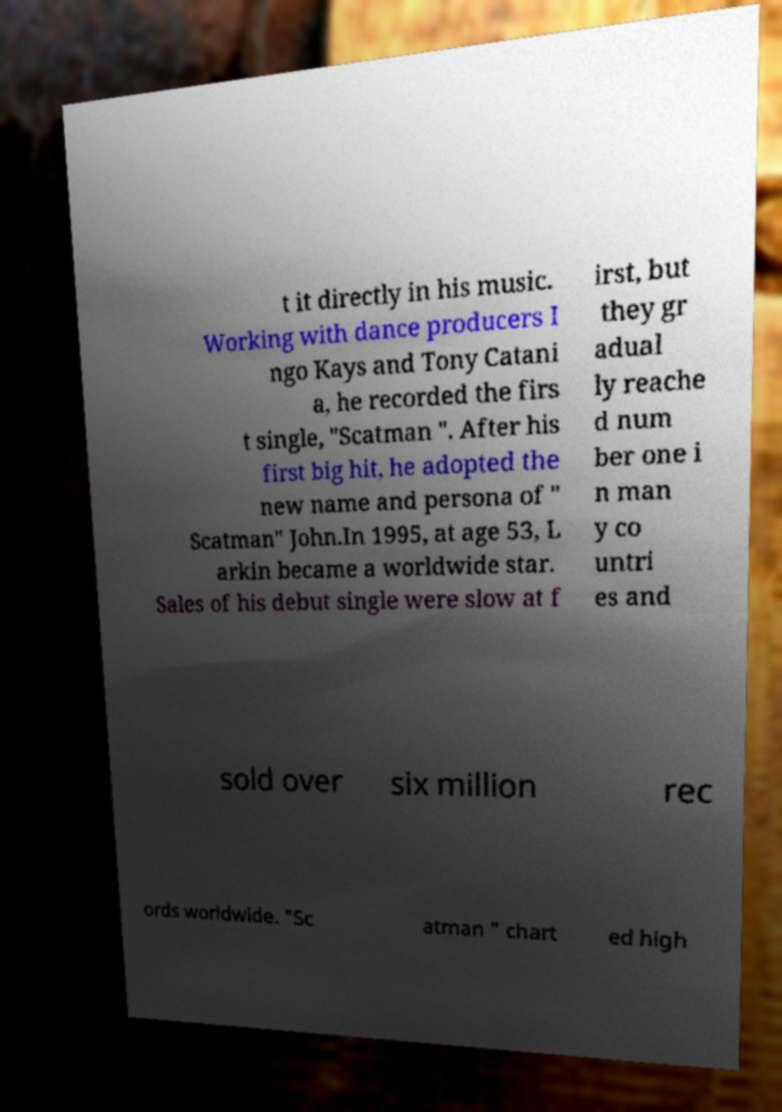I need the written content from this picture converted into text. Can you do that? t it directly in his music. Working with dance producers I ngo Kays and Tony Catani a, he recorded the firs t single, "Scatman ". After his first big hit, he adopted the new name and persona of " Scatman" John.In 1995, at age 53, L arkin became a worldwide star. Sales of his debut single were slow at f irst, but they gr adual ly reache d num ber one i n man y co untri es and sold over six million rec ords worldwide. "Sc atman " chart ed high 